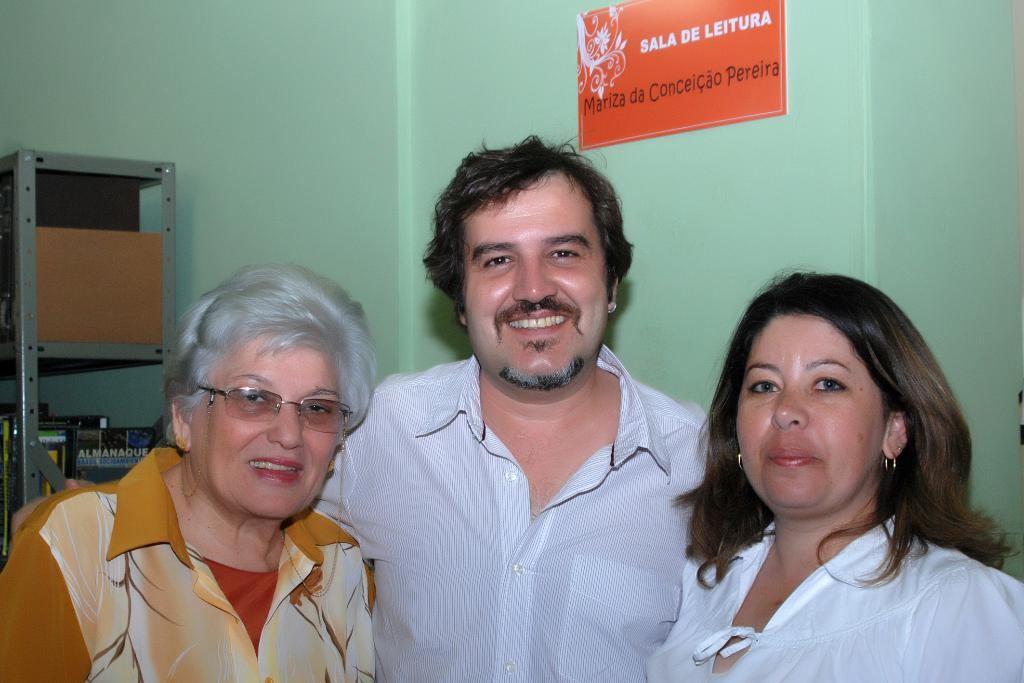Where was the image taken? The image was taken inside a room. How many people are in the image? There are three people in the image. Can you describe the gender of the people in the image? Two of the people are women, and one is a man. What is attached to the top of the image? There is a paper pasted at the top of the image. What can be seen on the left side of the image? There is a rack on the left side of the image. What year is depicted on the zipper of the man's jacket in the image? There is no zipper visible in the image, and therefore no year can be determined. 